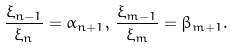<formula> <loc_0><loc_0><loc_500><loc_500>\frac { \xi _ { n - 1 } } { \xi _ { n } } = \alpha _ { n + 1 } , \, \frac { \xi _ { m - 1 } } { \xi _ { m } } = \beta _ { m + 1 } .</formula> 